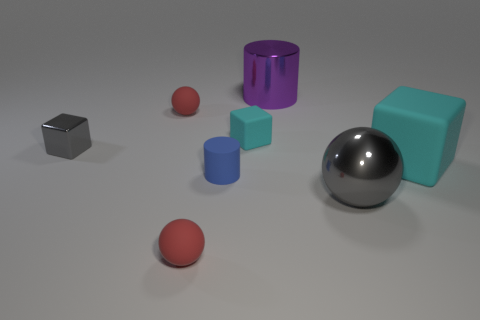Subtract all gray blocks. How many red balls are left? 2 Subtract all tiny matte spheres. How many spheres are left? 1 Add 1 small yellow spheres. How many objects exist? 9 Subtract 1 cubes. How many cubes are left? 2 Subtract all spheres. How many objects are left? 5 Subtract all big cyan rubber objects. Subtract all gray metallic balls. How many objects are left? 6 Add 4 purple metallic cylinders. How many purple metallic cylinders are left? 5 Add 4 purple cylinders. How many purple cylinders exist? 5 Subtract 0 yellow cubes. How many objects are left? 8 Subtract all brown cubes. Subtract all purple cylinders. How many cubes are left? 3 